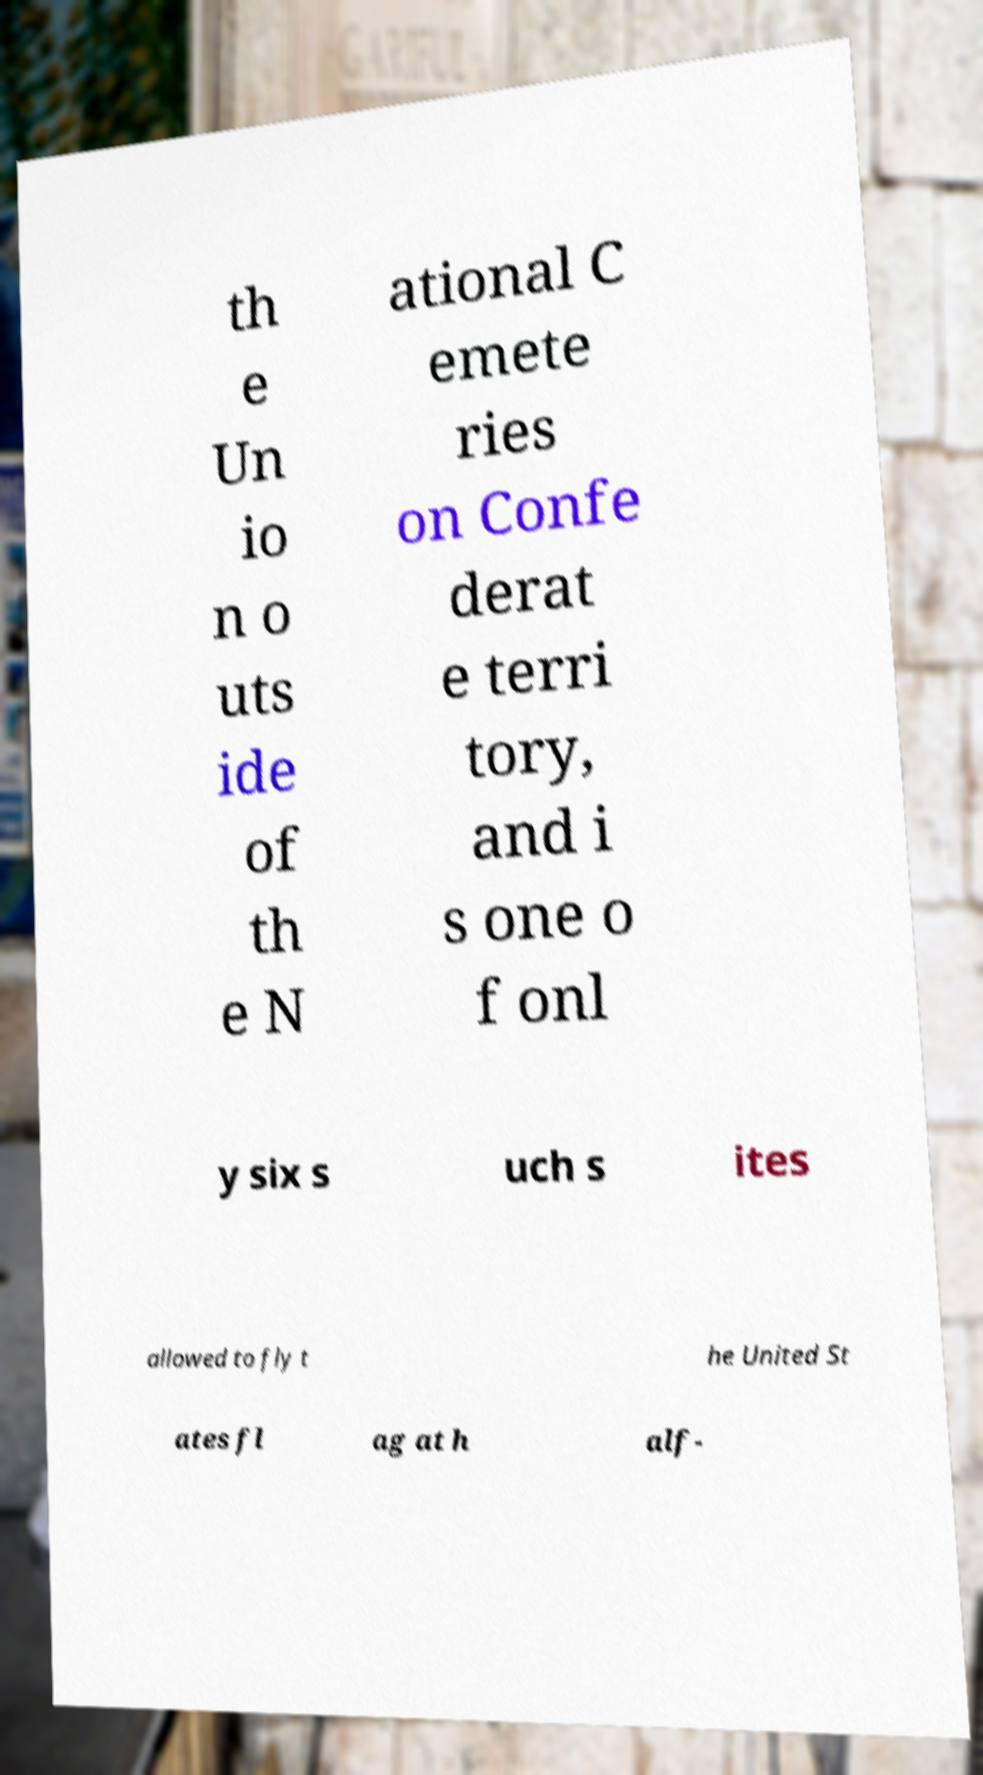There's text embedded in this image that I need extracted. Can you transcribe it verbatim? th e Un io n o uts ide of th e N ational C emete ries on Confe derat e terri tory, and i s one o f onl y six s uch s ites allowed to fly t he United St ates fl ag at h alf- 